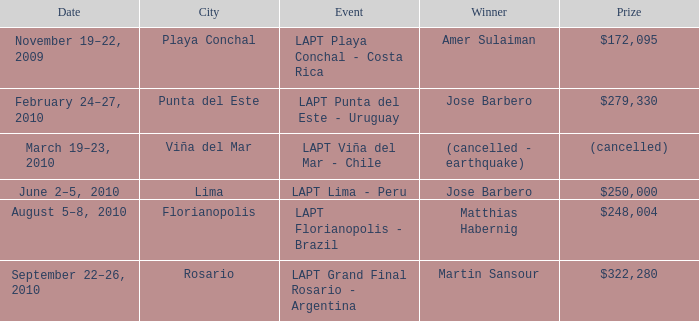What event is in florianopolis? LAPT Florianopolis - Brazil. 